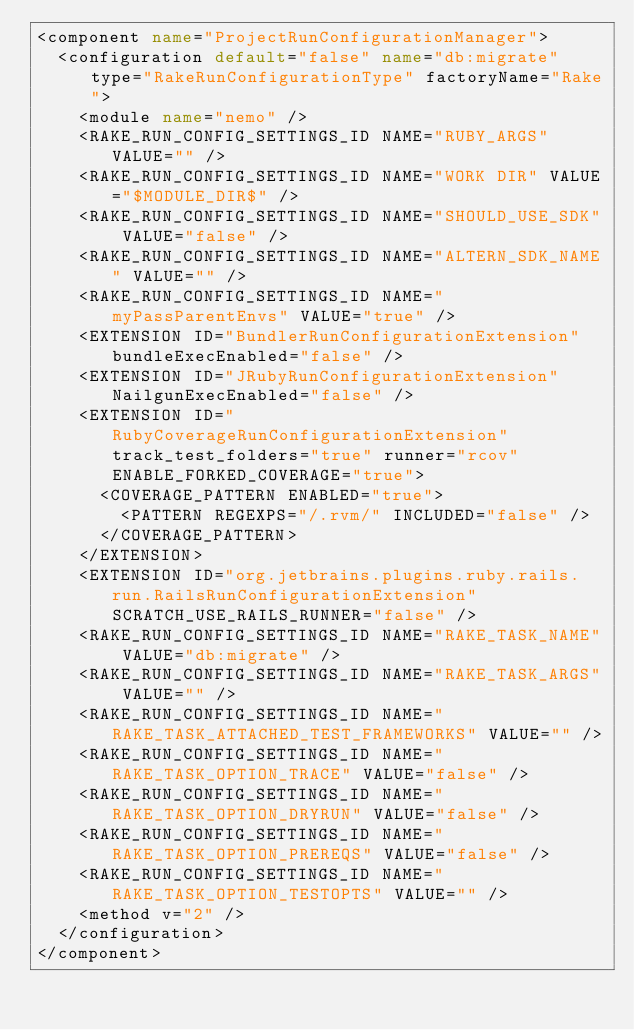Convert code to text. <code><loc_0><loc_0><loc_500><loc_500><_XML_><component name="ProjectRunConfigurationManager">
  <configuration default="false" name="db:migrate" type="RakeRunConfigurationType" factoryName="Rake">
    <module name="nemo" />
    <RAKE_RUN_CONFIG_SETTINGS_ID NAME="RUBY_ARGS" VALUE="" />
    <RAKE_RUN_CONFIG_SETTINGS_ID NAME="WORK DIR" VALUE="$MODULE_DIR$" />
    <RAKE_RUN_CONFIG_SETTINGS_ID NAME="SHOULD_USE_SDK" VALUE="false" />
    <RAKE_RUN_CONFIG_SETTINGS_ID NAME="ALTERN_SDK_NAME" VALUE="" />
    <RAKE_RUN_CONFIG_SETTINGS_ID NAME="myPassParentEnvs" VALUE="true" />
    <EXTENSION ID="BundlerRunConfigurationExtension" bundleExecEnabled="false" />
    <EXTENSION ID="JRubyRunConfigurationExtension" NailgunExecEnabled="false" />
    <EXTENSION ID="RubyCoverageRunConfigurationExtension" track_test_folders="true" runner="rcov" ENABLE_FORKED_COVERAGE="true">
      <COVERAGE_PATTERN ENABLED="true">
        <PATTERN REGEXPS="/.rvm/" INCLUDED="false" />
      </COVERAGE_PATTERN>
    </EXTENSION>
    <EXTENSION ID="org.jetbrains.plugins.ruby.rails.run.RailsRunConfigurationExtension" SCRATCH_USE_RAILS_RUNNER="false" />
    <RAKE_RUN_CONFIG_SETTINGS_ID NAME="RAKE_TASK_NAME" VALUE="db:migrate" />
    <RAKE_RUN_CONFIG_SETTINGS_ID NAME="RAKE_TASK_ARGS" VALUE="" />
    <RAKE_RUN_CONFIG_SETTINGS_ID NAME="RAKE_TASK_ATTACHED_TEST_FRAMEWORKS" VALUE="" />
    <RAKE_RUN_CONFIG_SETTINGS_ID NAME="RAKE_TASK_OPTION_TRACE" VALUE="false" />
    <RAKE_RUN_CONFIG_SETTINGS_ID NAME="RAKE_TASK_OPTION_DRYRUN" VALUE="false" />
    <RAKE_RUN_CONFIG_SETTINGS_ID NAME="RAKE_TASK_OPTION_PREREQS" VALUE="false" />
    <RAKE_RUN_CONFIG_SETTINGS_ID NAME="RAKE_TASK_OPTION_TESTOPTS" VALUE="" />
    <method v="2" />
  </configuration>
</component></code> 